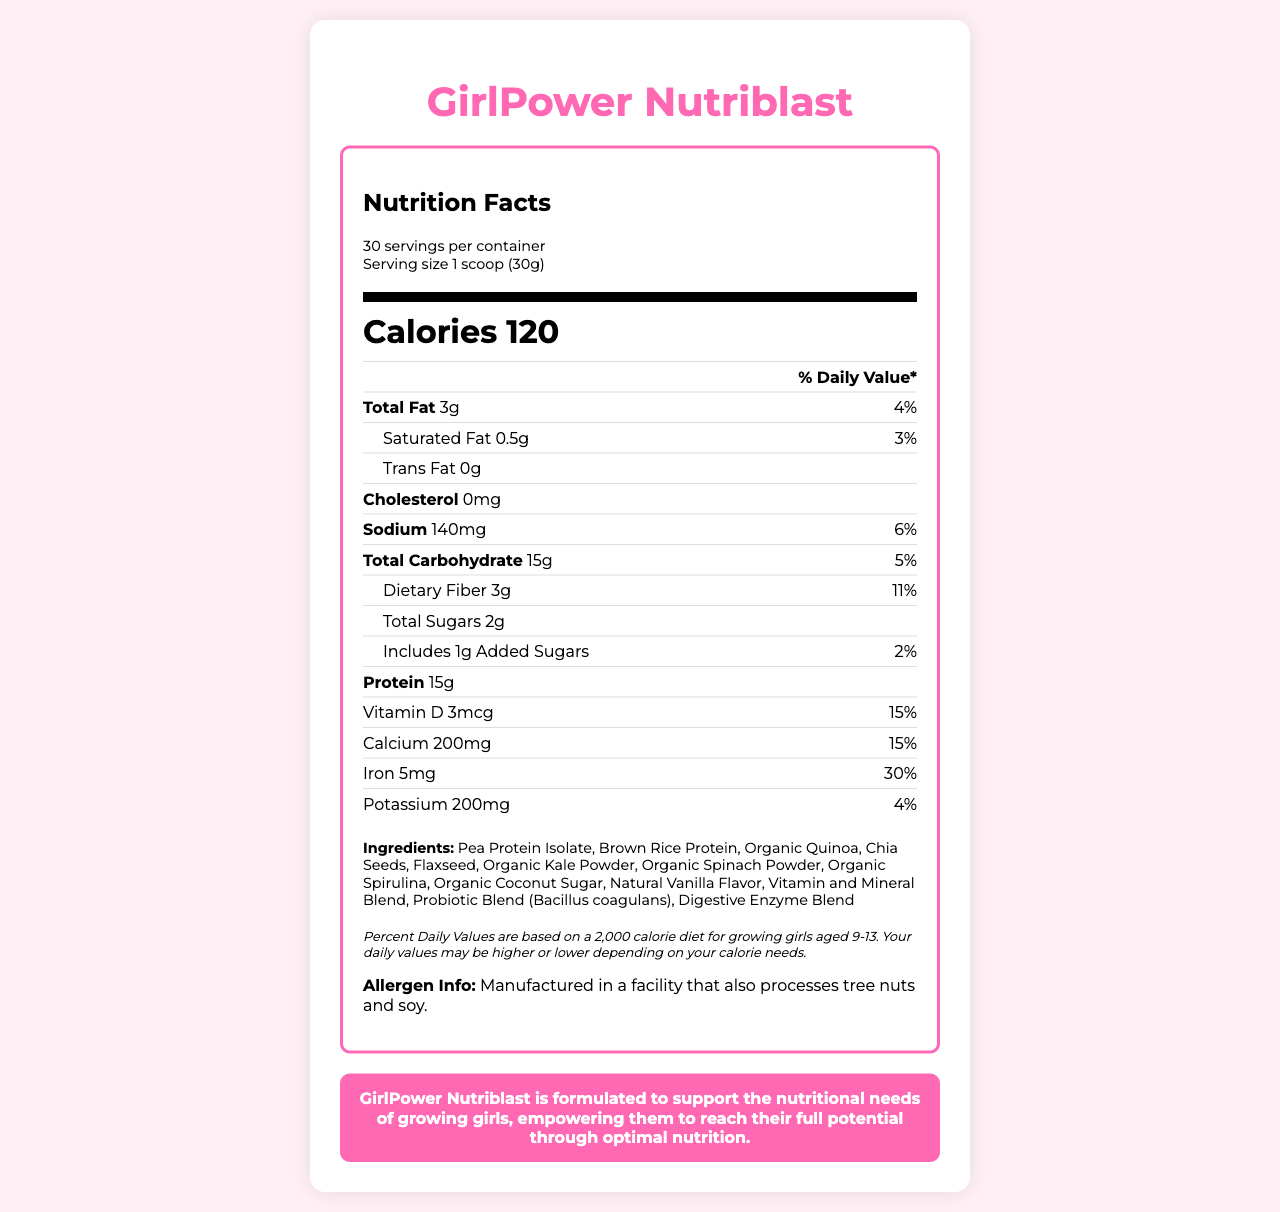what is the serving size? The serving size is listed under the "Nutrition Facts" heading and states "Serving size 1 scoop (30g)".
Answer: 1 scoop (30g) how many calories are in one serving? The number of calories per serving is listed prominently as "Calories 120" in the middle section of the nutrition label.
Answer: 120 what is the daily value percentage of iron per serving? The daily value percentage of iron is indicated in the section that lists the different nutrients and their daily values.
Answer: 30% how much total fat is in one serving? The amount of total fat per serving is listed as "Total Fat 3g" in the nutrient rows.
Answer: 3g what is one main ingredient of GirlPower Nutriblast? "Pea Protein Isolate" is one of the ingredients listed in the ingredients section.
Answer: Pea Protein Isolate which nutrient has the highest daily value percentage? A. Vitamin A B. Vitamin E C. Iron Vitamin E has the highest daily value percentage at "70%", as listed in the document.
Answer: B how many servings are there in the entire container? The number of servings per container is listed under "Nutrition Facts" as "30 servings per container".
Answer: 30 True or False: GirlPower Nutriblast contains trans fat. The label lists "Trans Fat 0g", indicating there are no trans fats in the product.
Answer: False what percentage of daily value of dietary fiber does one serving provide? The daily value for dietary fiber is specified as "11%" under the dietary fiber section.
Answer: 11% how much cholesterol is in one serving? The cholesterol content is listed as "Cholesterol 0mg", indicating there is no cholesterol in the product.
Answer: 0mg what is the amount of added sugars in one serving? The document lists "Includes 1g Added Sugars" in the nutrient row.
Answer: 1g what statement summarizes the purpose of GirlPower Nutriblast? This summary is given in the document's brand statement at the bottom.
Answer: GirlPower Nutriblast is formulated to support the nutritional needs of growing girls, empowering them to reach their full potential through optimal nutrition. which group is the target audience for this product? The disclaimer specifies that percent daily values are based on a 2,000 calorie diet for growing girls aged 9-13.
Answer: Growing girls aged 9-13 is the product manufactured in a facility that processes allergens? The allergen information states, "Manufactured in a facility that also processes tree nuts and soy."
Answer: Yes which ingredient is not listed in the document? A. Chia Seeds B. Whey Protein C. Organic Quinoa Whey Protein is not listed among the ingredients, whereas the other options are.
Answer: B how much vitamin C is in one serving? The amount of vitamin C per serving is listed in the nutrient rows under "Vitamin C 30mg".
Answer: 30mg can the exact cost of the product be determined from the document? The document does not provide any pricing information, so the exact cost cannot be determined.
Answer: Not enough information 